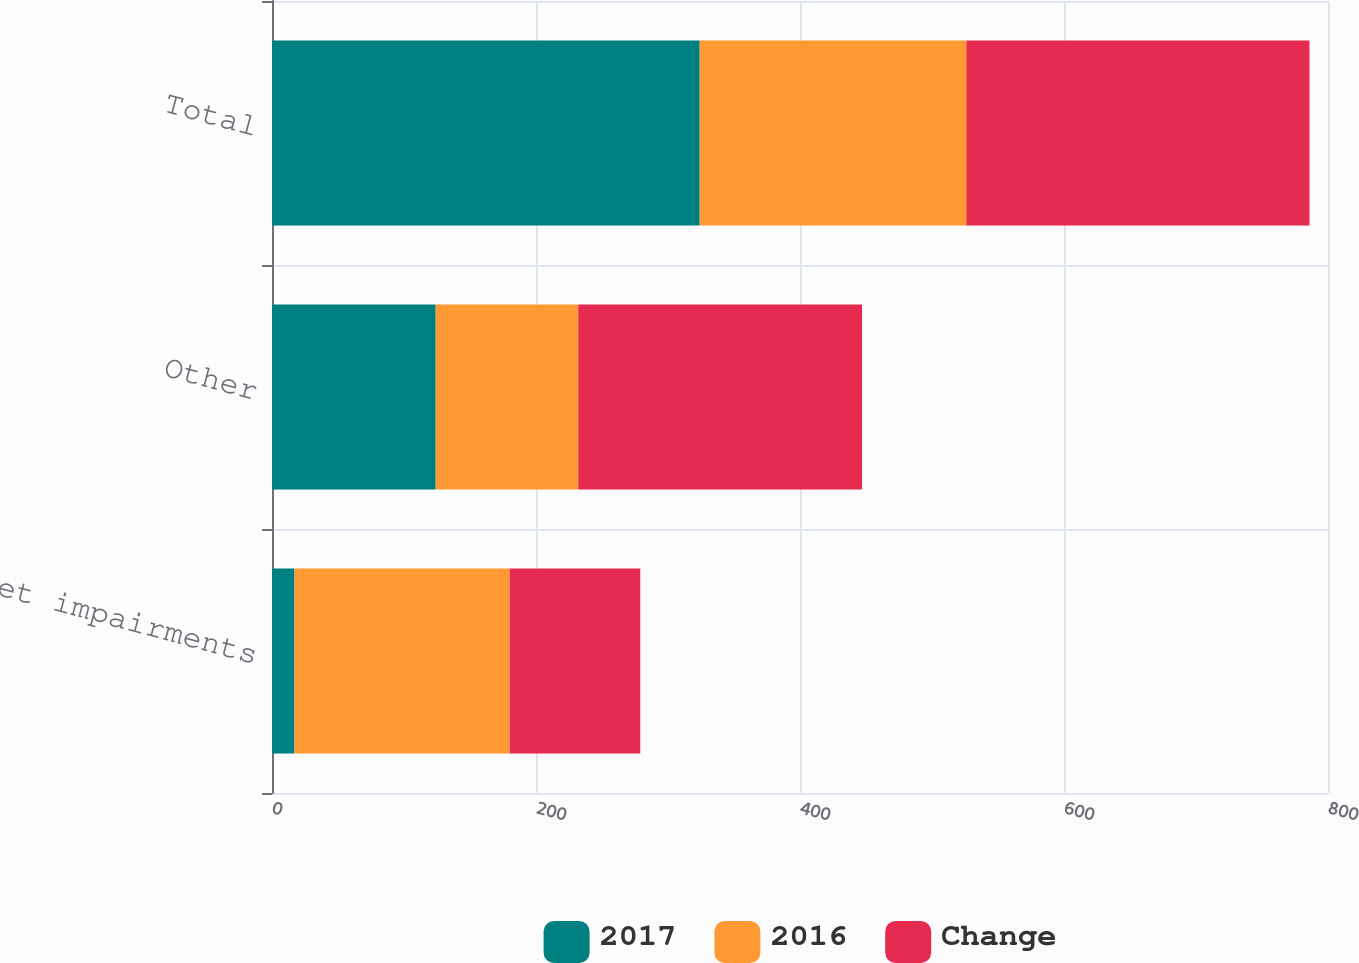Convert chart to OTSL. <chart><loc_0><loc_0><loc_500><loc_500><stacked_bar_chart><ecel><fcel>Asset impairments<fcel>Other<fcel>Total<nl><fcel>2017<fcel>17<fcel>124<fcel>324<nl><fcel>2016<fcel>163<fcel>108<fcel>202<nl><fcel>Change<fcel>99<fcel>215<fcel>260<nl></chart> 